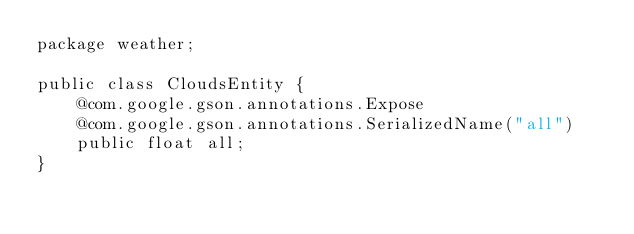Convert code to text. <code><loc_0><loc_0><loc_500><loc_500><_Java_>package weather;

public class CloudsEntity {
    @com.google.gson.annotations.Expose
    @com.google.gson.annotations.SerializedName("all")
    public float all;
}
</code> 